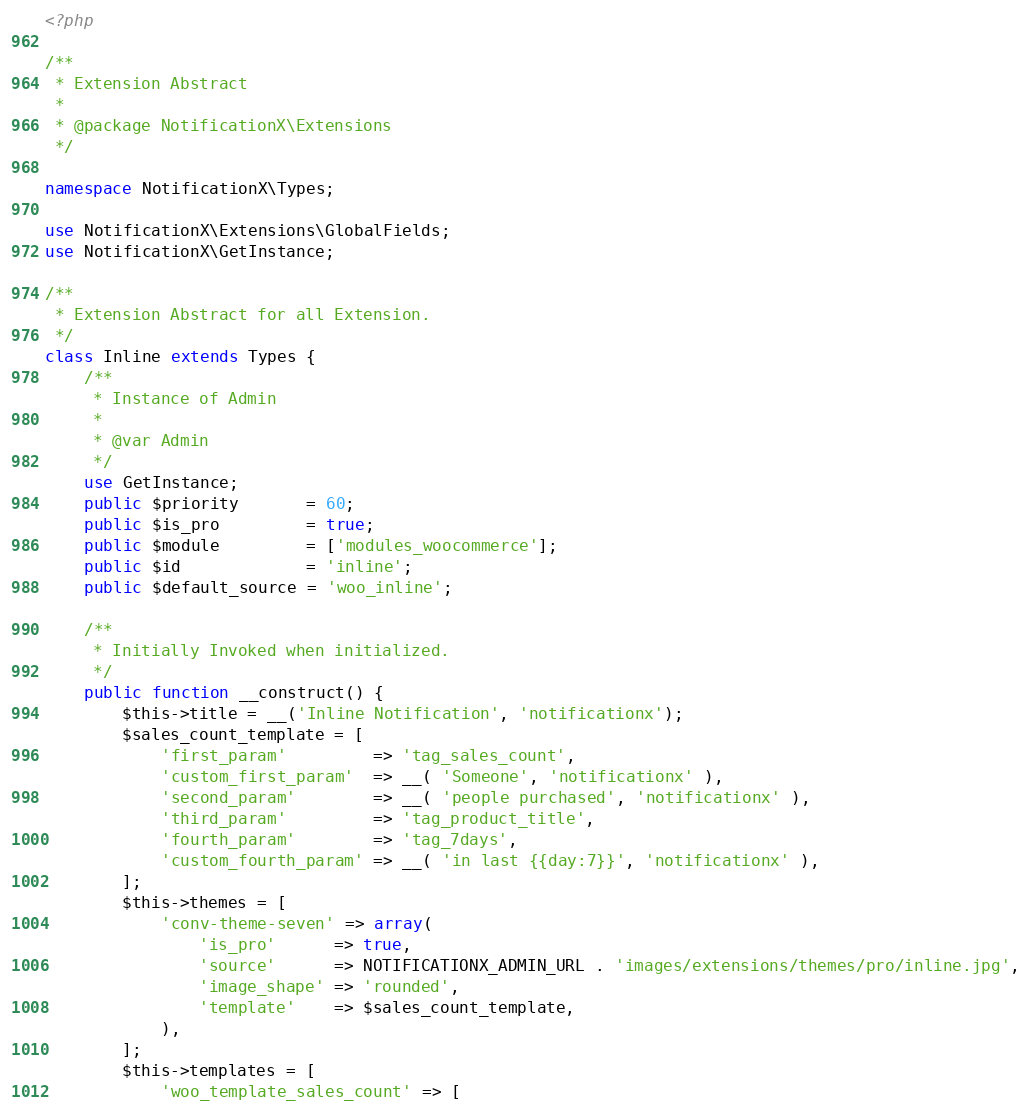<code> <loc_0><loc_0><loc_500><loc_500><_PHP_><?php

/**
 * Extension Abstract
 *
 * @package NotificationX\Extensions
 */

namespace NotificationX\Types;

use NotificationX\Extensions\GlobalFields;
use NotificationX\GetInstance;

/**
 * Extension Abstract for all Extension.
 */
class Inline extends Types {
    /**
     * Instance of Admin
     *
     * @var Admin
     */
    use GetInstance;
    public $priority       = 60;
    public $is_pro         = true;
    public $module         = ['modules_woocommerce'];
    public $id             = 'inline';
    public $default_source = 'woo_inline';

    /**
     * Initially Invoked when initialized.
     */
    public function __construct() {
        $this->title = __('Inline Notification', 'notificationx');
        $sales_count_template = [
            'first_param'         => 'tag_sales_count',
            'custom_first_param'  => __( 'Someone', 'notificationx' ),
            'second_param'        => __( 'people purchased', 'notificationx' ),
            'third_param'         => 'tag_product_title',
            'fourth_param'        => 'tag_7days',
            'custom_fourth_param' => __( 'in last {{day:7}}', 'notificationx' ),
        ];
        $this->themes = [
            'conv-theme-seven' => array(
                'is_pro'      => true,
                'source'      => NOTIFICATIONX_ADMIN_URL . 'images/extensions/themes/pro/inline.jpg',
                'image_shape' => 'rounded',
                'template'    => $sales_count_template,
            ),
        ];
        $this->templates = [
            'woo_template_sales_count' => [</code> 